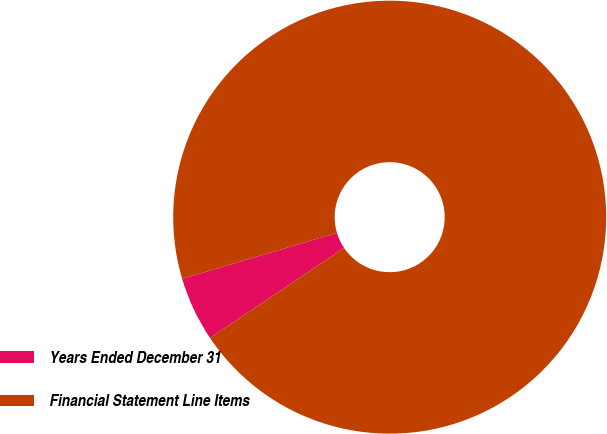Convert chart. <chart><loc_0><loc_0><loc_500><loc_500><pie_chart><fcel>Years Ended December 31<fcel>Financial Statement Line Items<nl><fcel>4.82%<fcel>95.18%<nl></chart> 